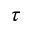<formula> <loc_0><loc_0><loc_500><loc_500>\tau</formula> 